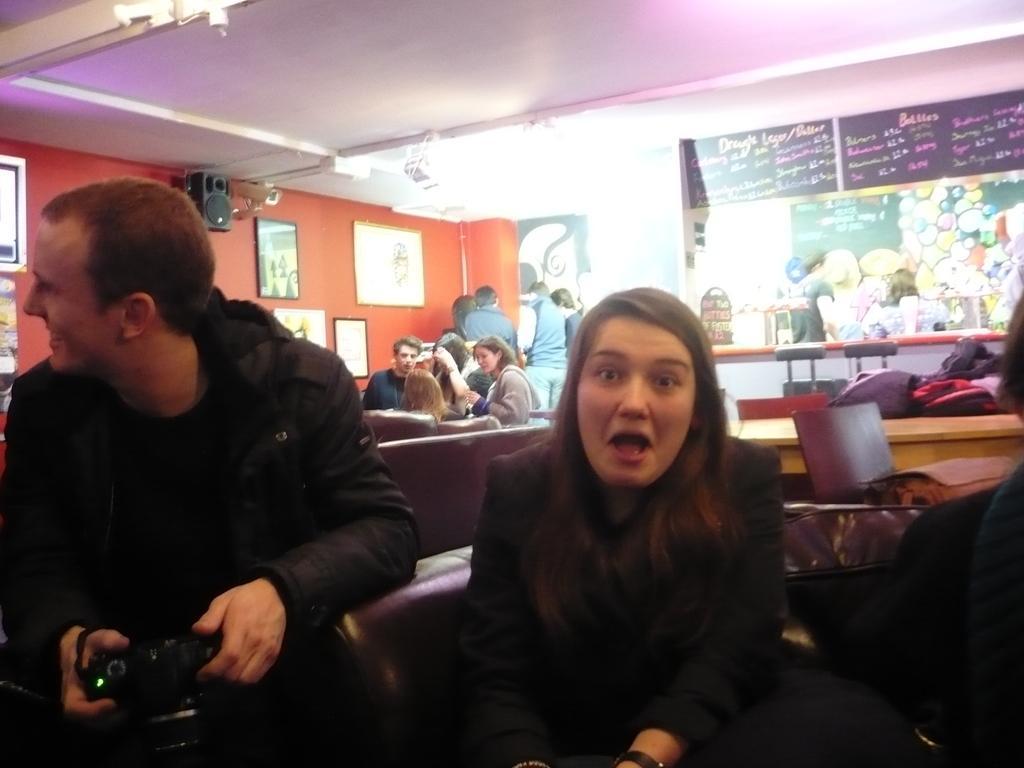In one or two sentences, can you explain what this image depicts? The men wearing black dress is holding a camera in his hands and there's another girl sitting beside him and there are group of people behind them. 